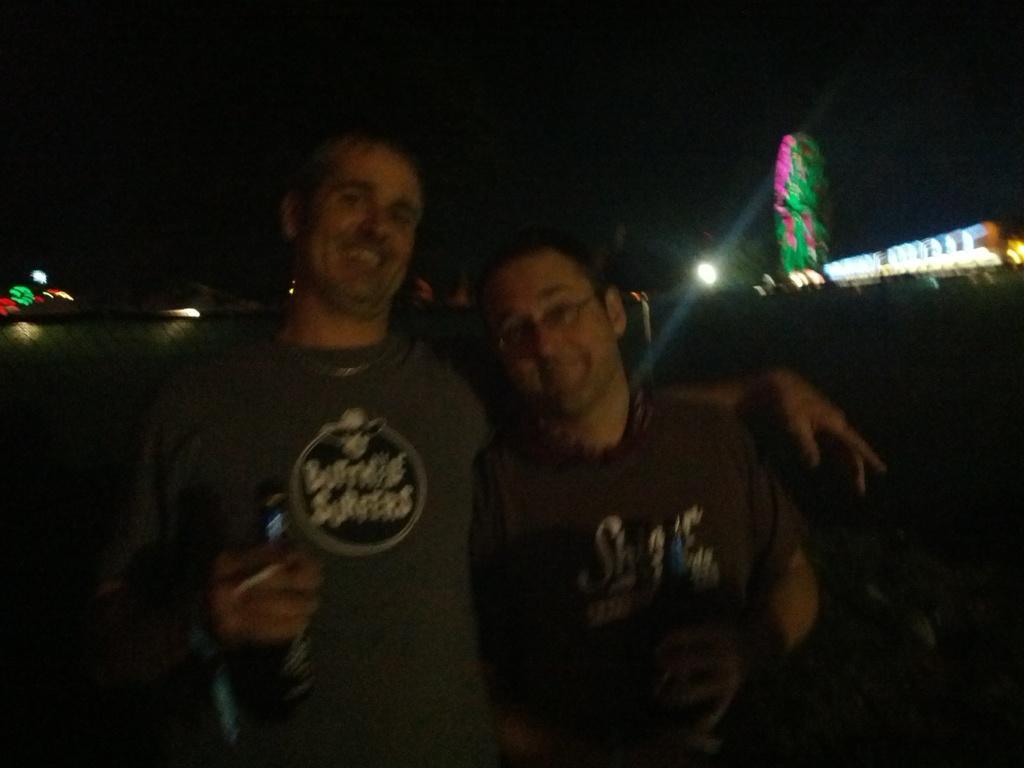Could you give a brief overview of what you see in this image? In this image, we can see two persons wearing clothes. 